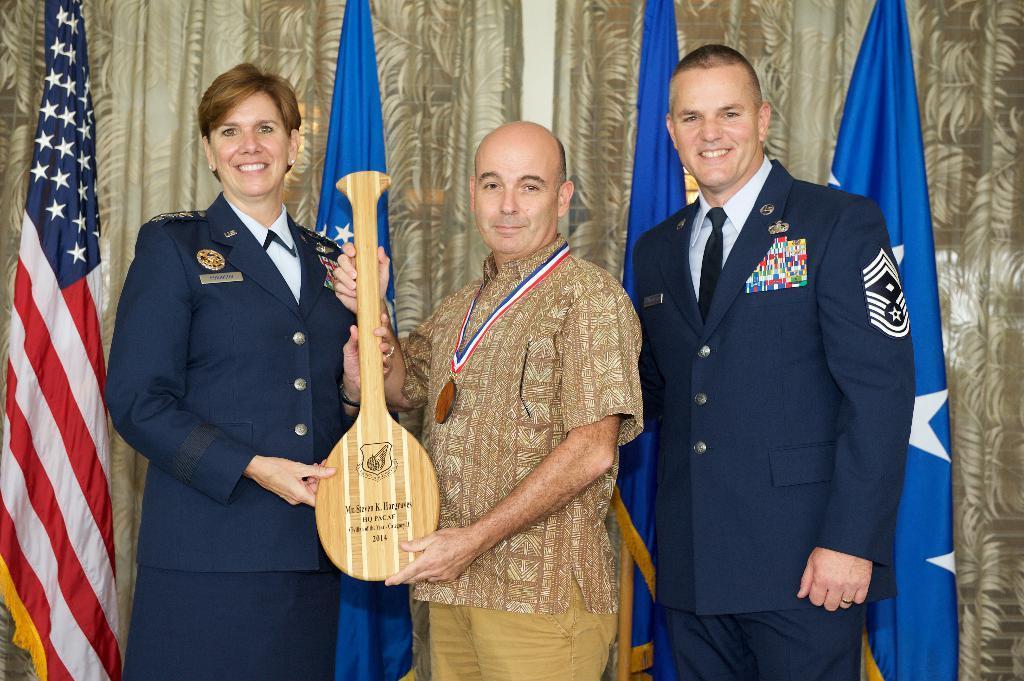Describe this image in one or two sentences. In this image we can see a group of people are standing, and smiling, and holding a musical instrument in the hand, here a man is wearing the suit, at back here is the flag, here is the curtain. 